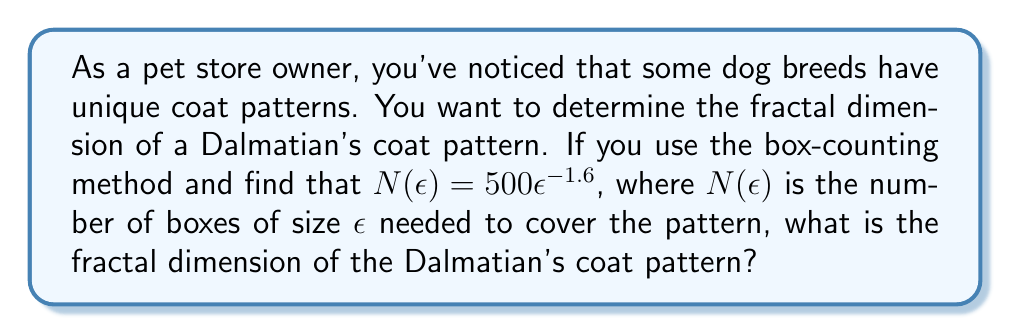Show me your answer to this math problem. To determine the fractal dimension using the box-counting method, we follow these steps:

1. Recall the box-counting formula:
   $$N(\epsilon) = k\epsilon^{-D}$$
   where $N(\epsilon)$ is the number of boxes, $\epsilon$ is the box size, $k$ is a constant, and $D$ is the fractal dimension.

2. In our case, we're given:
   $$N(\epsilon) = 500\epsilon^{-1.6}$$

3. Comparing this to the general formula, we can see that:
   $k = 500$
   $D = 1.6$

4. The fractal dimension $D$ is the exponent in the box-counting formula, which in this case is 1.6.

Therefore, the fractal dimension of the Dalmatian's coat pattern is 1.6.
Answer: 1.6 